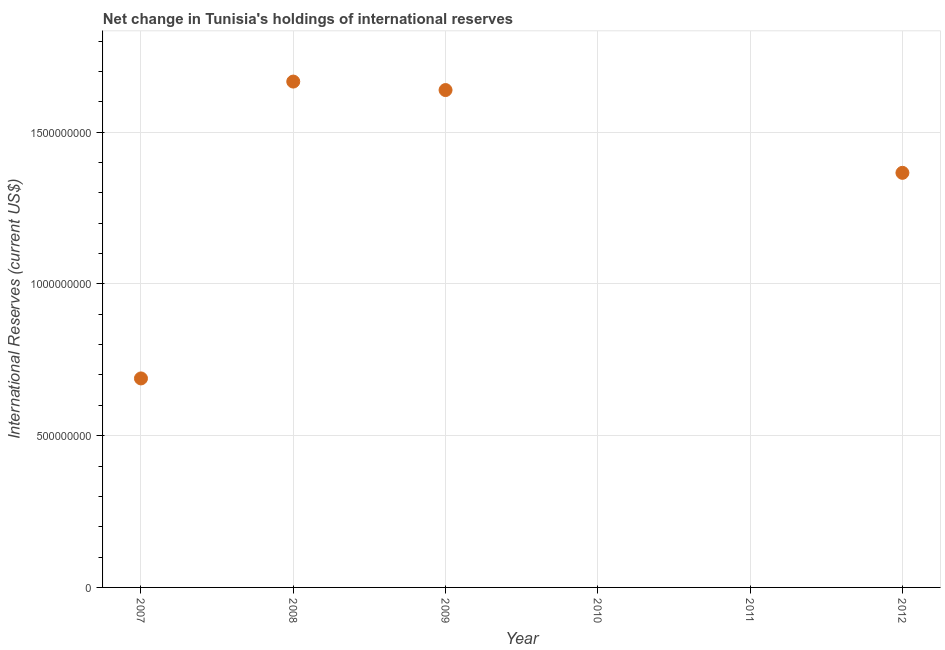What is the reserves and related items in 2007?
Give a very brief answer. 6.89e+08. Across all years, what is the maximum reserves and related items?
Provide a short and direct response. 1.67e+09. What is the sum of the reserves and related items?
Ensure brevity in your answer.  5.36e+09. What is the difference between the reserves and related items in 2007 and 2008?
Make the answer very short. -9.78e+08. What is the average reserves and related items per year?
Ensure brevity in your answer.  8.93e+08. What is the median reserves and related items?
Give a very brief answer. 1.03e+09. In how many years, is the reserves and related items greater than 700000000 US$?
Ensure brevity in your answer.  3. What is the ratio of the reserves and related items in 2007 to that in 2012?
Keep it short and to the point. 0.5. What is the difference between the highest and the second highest reserves and related items?
Make the answer very short. 2.79e+07. Is the sum of the reserves and related items in 2007 and 2009 greater than the maximum reserves and related items across all years?
Your answer should be compact. Yes. What is the difference between the highest and the lowest reserves and related items?
Offer a terse response. 1.67e+09. How many years are there in the graph?
Give a very brief answer. 6. What is the difference between two consecutive major ticks on the Y-axis?
Ensure brevity in your answer.  5.00e+08. Are the values on the major ticks of Y-axis written in scientific E-notation?
Provide a short and direct response. No. What is the title of the graph?
Keep it short and to the point. Net change in Tunisia's holdings of international reserves. What is the label or title of the X-axis?
Ensure brevity in your answer.  Year. What is the label or title of the Y-axis?
Keep it short and to the point. International Reserves (current US$). What is the International Reserves (current US$) in 2007?
Provide a succinct answer. 6.89e+08. What is the International Reserves (current US$) in 2008?
Ensure brevity in your answer.  1.67e+09. What is the International Reserves (current US$) in 2009?
Your answer should be compact. 1.64e+09. What is the International Reserves (current US$) in 2012?
Provide a short and direct response. 1.37e+09. What is the difference between the International Reserves (current US$) in 2007 and 2008?
Ensure brevity in your answer.  -9.78e+08. What is the difference between the International Reserves (current US$) in 2007 and 2009?
Ensure brevity in your answer.  -9.50e+08. What is the difference between the International Reserves (current US$) in 2007 and 2012?
Provide a succinct answer. -6.77e+08. What is the difference between the International Reserves (current US$) in 2008 and 2009?
Your answer should be compact. 2.79e+07. What is the difference between the International Reserves (current US$) in 2008 and 2012?
Your answer should be very brief. 3.01e+08. What is the difference between the International Reserves (current US$) in 2009 and 2012?
Provide a short and direct response. 2.73e+08. What is the ratio of the International Reserves (current US$) in 2007 to that in 2008?
Your answer should be very brief. 0.41. What is the ratio of the International Reserves (current US$) in 2007 to that in 2009?
Your answer should be compact. 0.42. What is the ratio of the International Reserves (current US$) in 2007 to that in 2012?
Give a very brief answer. 0.5. What is the ratio of the International Reserves (current US$) in 2008 to that in 2009?
Provide a short and direct response. 1.02. What is the ratio of the International Reserves (current US$) in 2008 to that in 2012?
Offer a terse response. 1.22. 